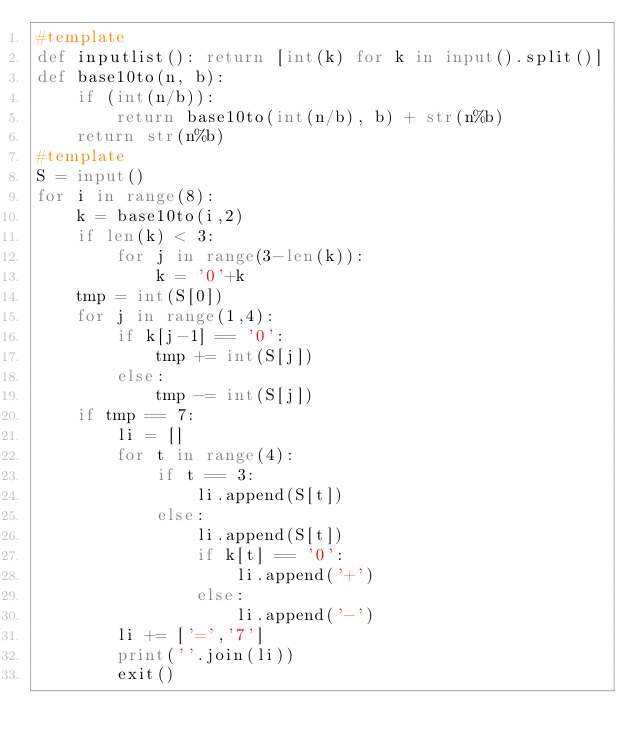<code> <loc_0><loc_0><loc_500><loc_500><_Python_>#template
def inputlist(): return [int(k) for k in input().split()]
def base10to(n, b):
    if (int(n/b)):
        return base10to(int(n/b), b) + str(n%b)
    return str(n%b)
#template
S = input()
for i in range(8):
    k = base10to(i,2)
    if len(k) < 3:
        for j in range(3-len(k)):
            k = '0'+k
    tmp = int(S[0])
    for j in range(1,4):
        if k[j-1] == '0':
            tmp += int(S[j])
        else:
            tmp -= int(S[j])
    if tmp == 7:
        li = []
        for t in range(4):
            if t == 3:
                li.append(S[t])
            else:
                li.append(S[t])
                if k[t] == '0':
                    li.append('+')
                else:
                    li.append('-')
        li += ['=','7']
        print(''.join(li))
        exit()</code> 